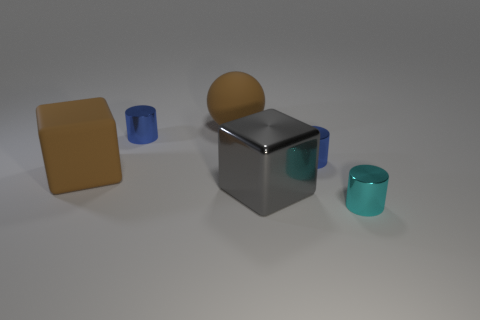Are there any other large shiny blocks of the same color as the large shiny block?
Provide a short and direct response. No. Is the gray metallic object the same size as the cyan thing?
Offer a terse response. No. There is a brown object that is in front of the blue metallic cylinder that is left of the gray block; what size is it?
Your response must be concise. Large. What is the size of the thing that is both behind the brown block and on the left side of the sphere?
Keep it short and to the point. Small. What number of spheres are the same size as the brown matte block?
Your response must be concise. 1. How many metal things are cubes or red spheres?
Provide a succinct answer. 1. There is a matte object that is the same color as the rubber sphere; what size is it?
Offer a very short reply. Large. What material is the block on the right side of the matte thing on the right side of the large brown block?
Keep it short and to the point. Metal. How many things are small cylinders or shiny cylinders that are behind the big matte cube?
Offer a very short reply. 3. There is a gray cube that is made of the same material as the small cyan cylinder; what size is it?
Offer a very short reply. Large. 